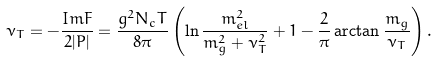Convert formula to latex. <formula><loc_0><loc_0><loc_500><loc_500>\nu _ { T } = - { \frac { I m F } { 2 | P | } } = { \frac { g ^ { 2 } N _ { c } T } { 8 \pi } } \left ( \ln { \frac { m _ { e l } ^ { 2 } } { m _ { g } ^ { 2 } + \nu _ { T } ^ { 2 } } } + 1 - { \frac { 2 } { \pi } } \arctan { \frac { m _ { g } } { \nu _ { T } } } \right ) .</formula> 